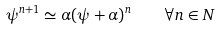Convert formula to latex. <formula><loc_0><loc_0><loc_500><loc_500>\psi ^ { n + 1 } \simeq \alpha ( \psi + \alpha ) ^ { n } \quad \forall n \in N</formula> 